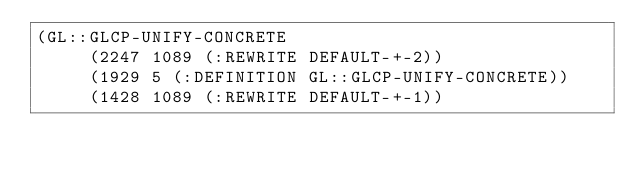Convert code to text. <code><loc_0><loc_0><loc_500><loc_500><_Lisp_>(GL::GLCP-UNIFY-CONCRETE
     (2247 1089 (:REWRITE DEFAULT-+-2))
     (1929 5 (:DEFINITION GL::GLCP-UNIFY-CONCRETE))
     (1428 1089 (:REWRITE DEFAULT-+-1))</code> 